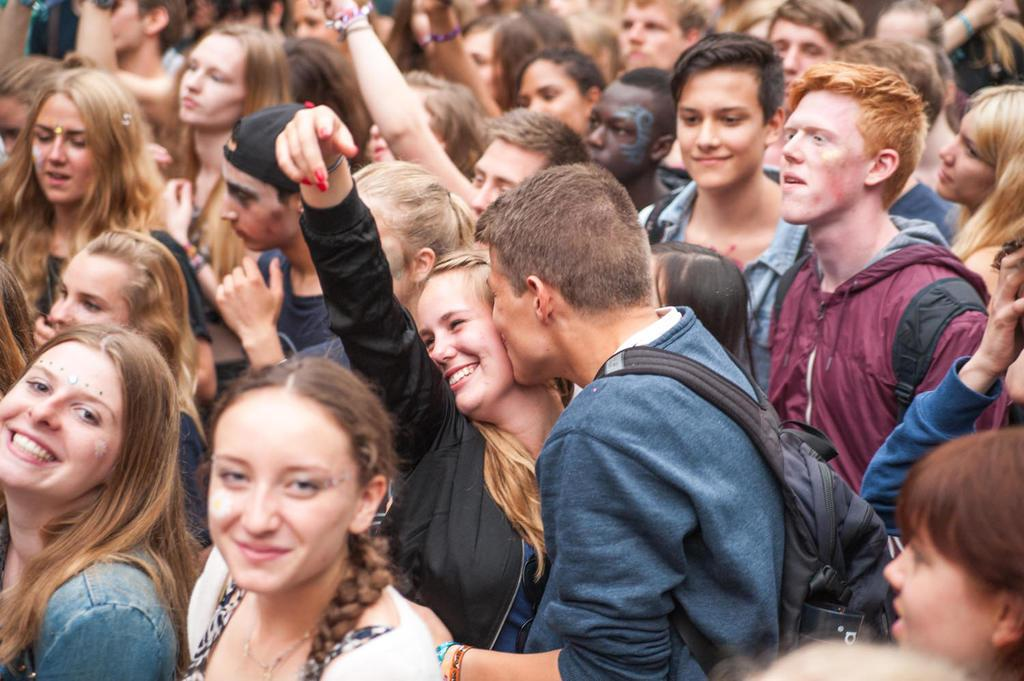What is happening in the image involving a group of people? There is a group of people in the image, and a man is kissing a woman in the group. Can you describe the man's attire in the image? The man is wearing a bag in the image. How are the people in the group feeling or expressing themselves? Some people in the group are smiling. What type of decision is the goat making in the image? There is no goat present in the image, so it is not possible to determine what decision it might be making. 